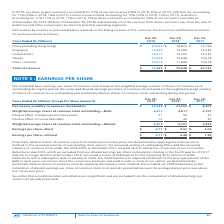From Intel Corporation's financial document, What are the basic earnings per share of common stock for the year 2017, 2018 and 2019 respectively? The document contains multiple relevant values: $2.04, $4.57, $4.77. From the document: "Earnings per share—Basic $ 4.77 $ 4.57 $ 2.04 Earnings per share—Basic $ 4.77 $ 4.57 $ 2.04 Earnings per share—Basic $ 4.77 $ 4.57 $ 2.04..." Also, What are the diluted earnings per share of common stock for the year 2017, 2018 and 2019 respectively? The document contains multiple relevant values: $1.99, $4.48, $4.71. From the document: "Earnings per share—Diluted $ 4.71 $ 4.48 $ 1.99 Earnings per share—Diluted $ 4.71 $ 4.48 $ 1.99 Earnings per share—Diluted $ 4.71 $ 4.48 $ 1.99..." Also, How are the potentially dilutive shares of common stock from employee incentive plans determined? By applying the treasury stock method to the assumed exercise of outstanding stock options, the assumed vesting of outstanding RSUs, and the assumed issuance of common stock under the 2006 ESPP.. The document states: "stock from employee incentive plans are determined by applying the treasury stock method to the assumed exercise of outstanding stock options, the ass..." Also, can you calculate: What is the percentage change of basic earnings per share of common stock from 2018 to 2019? To answer this question, I need to perform calculations using the financial data. The calculation is: (4.77 - 4.57) / 4.57 , which equals 4.38 (percentage). This is based on the information: "Earnings per share—Basic $ 4.77 $ 4.57 $ 2.04 Earnings per share—Basic $ 4.77 $ 4.57 $ 2.04..." The key data points involved are: 4.57, 4.77. Additionally, On which year does the dilutive effects have the largest impact on diluted earnings per share of common stock? According to the financial document, 2017. The relevant text states: "d for 41% of our net revenue (39% in 2018, 40% in 2017), with Dell Inc. accounting for 17% (16% in 2018, 16% in 2017), Lenovo Group Limited accounting for..." Also, can you calculate: What is the percentage change of net income available to common stockholders from 2017 to 2018? To answer this question, I need to perform calculations using the financial data. The calculation is: (21,053 - 9,601) / 9,601 , which equals 119.28 (percentage). This is based on the information: "ilable to common stockholders $ 21,048 $ 21,053 $ 9,601 ncome available to common stockholders $ 21,048 $ 21,053 $ 9,601..." The key data points involved are: 21,053, 9,601. 